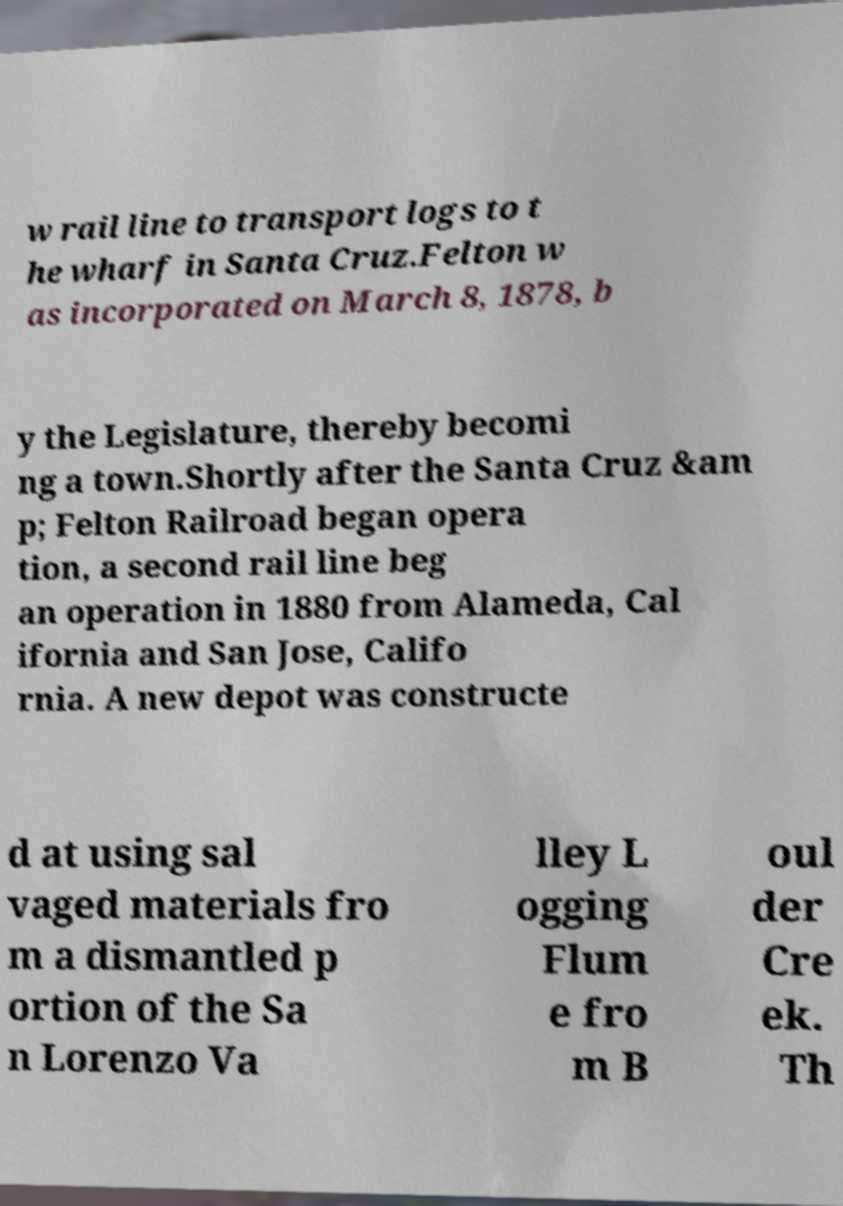Please identify and transcribe the text found in this image. w rail line to transport logs to t he wharf in Santa Cruz.Felton w as incorporated on March 8, 1878, b y the Legislature, thereby becomi ng a town.Shortly after the Santa Cruz &am p; Felton Railroad began opera tion, a second rail line beg an operation in 1880 from Alameda, Cal ifornia and San Jose, Califo rnia. A new depot was constructe d at using sal vaged materials fro m a dismantled p ortion of the Sa n Lorenzo Va lley L ogging Flum e fro m B oul der Cre ek. Th 